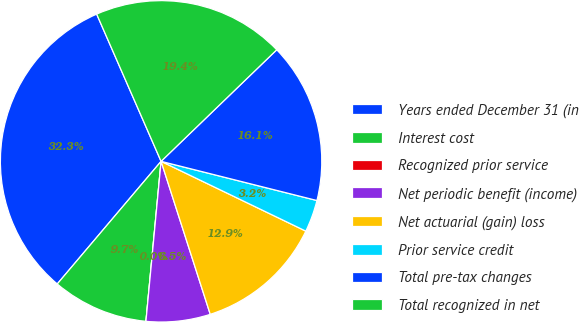Convert chart. <chart><loc_0><loc_0><loc_500><loc_500><pie_chart><fcel>Years ended December 31 (in<fcel>Interest cost<fcel>Recognized prior service<fcel>Net periodic benefit (income)<fcel>Net actuarial (gain) loss<fcel>Prior service credit<fcel>Total pre-tax changes<fcel>Total recognized in net<nl><fcel>32.25%<fcel>9.68%<fcel>0.0%<fcel>6.45%<fcel>12.9%<fcel>3.23%<fcel>16.13%<fcel>19.35%<nl></chart> 